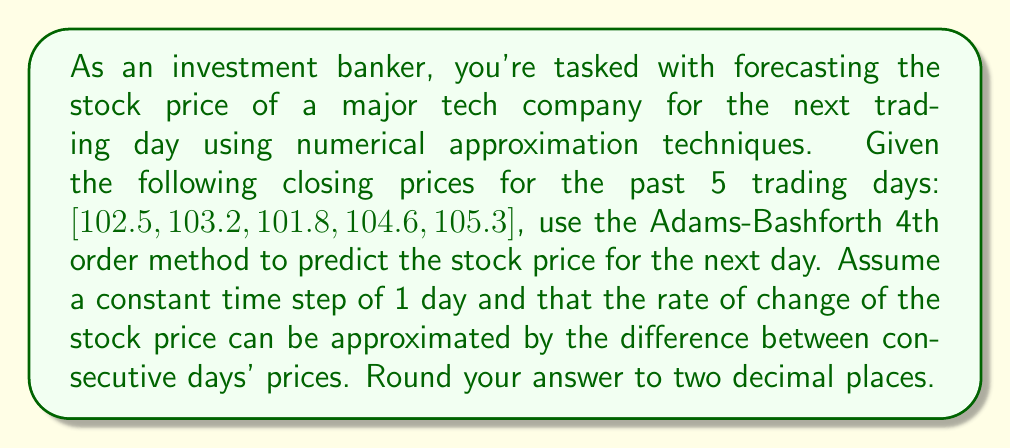Could you help me with this problem? To solve this problem, we'll use the Adams-Bashforth 4th order method, which is a linear multistep method for numerical integration. The general formula for the Adams-Bashforth 4th order method is:

$$y_{n+1} = y_n + \frac{h}{24}(55f_n - 59f_{n-1} + 37f_{n-2} - 9f_{n-3})$$

Where:
- $y_n$ is the current value
- $h$ is the step size (in this case, 1 day)
- $f_n$, $f_{n-1}$, $f_{n-2}$, and $f_{n-3}$ are the function values at the current and previous three steps

Step 1: Calculate the rate of change (difference) between consecutive days:
$f_4 = 105.3 - 104.6 = 0.7$
$f_3 = 104.6 - 101.8 = 2.8$
$f_2 = 101.8 - 103.2 = -1.4$
$f_1 = 103.2 - 102.5 = 0.7$

Step 2: Apply the Adams-Bashforth 4th order formula:

$$y_5 = 105.3 + \frac{1}{24}(55(0.7) - 59(2.8) + 37(-1.4) - 9(0.7))$$

Step 3: Simplify and calculate:

$$y_5 = 105.3 + \frac{1}{24}(38.5 - 165.2 - 51.8 - 6.3)$$
$$y_5 = 105.3 + \frac{-184.8}{24}$$
$$y_5 = 105.3 - 7.7$$
$$y_5 = 97.6$$

Therefore, the predicted stock price for the next trading day is $97.60.
Answer: $97.60 